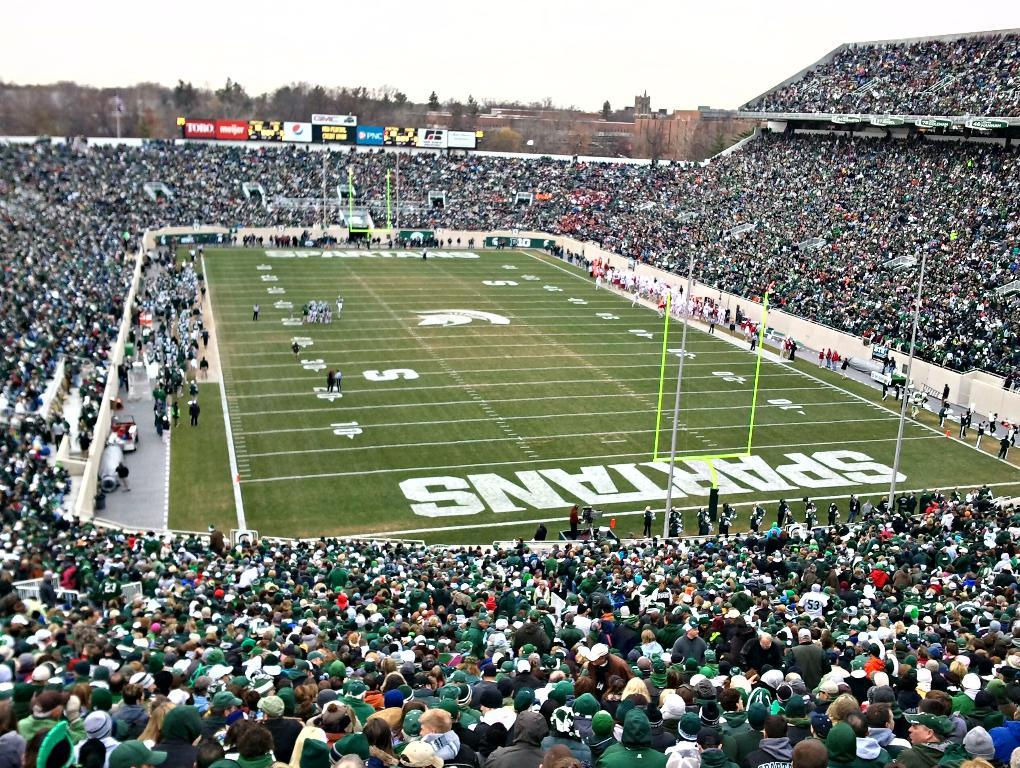<image>
Summarize the visual content of the image. A football field is filled with people and the team name Spartans on one end. 